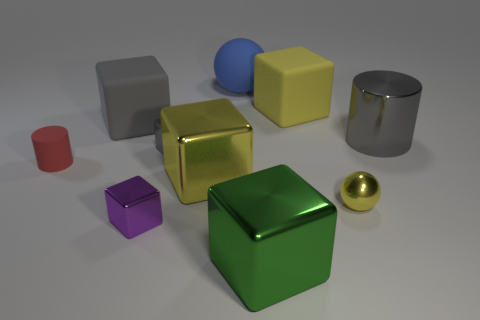What is the color of the large cylinder that is made of the same material as the purple object? The large cylinder shares its shiny metallic texture with the smaller purple cube. The color of this cylinder is gray with a polished surface that reflects light, giving it a glossy appearance. 